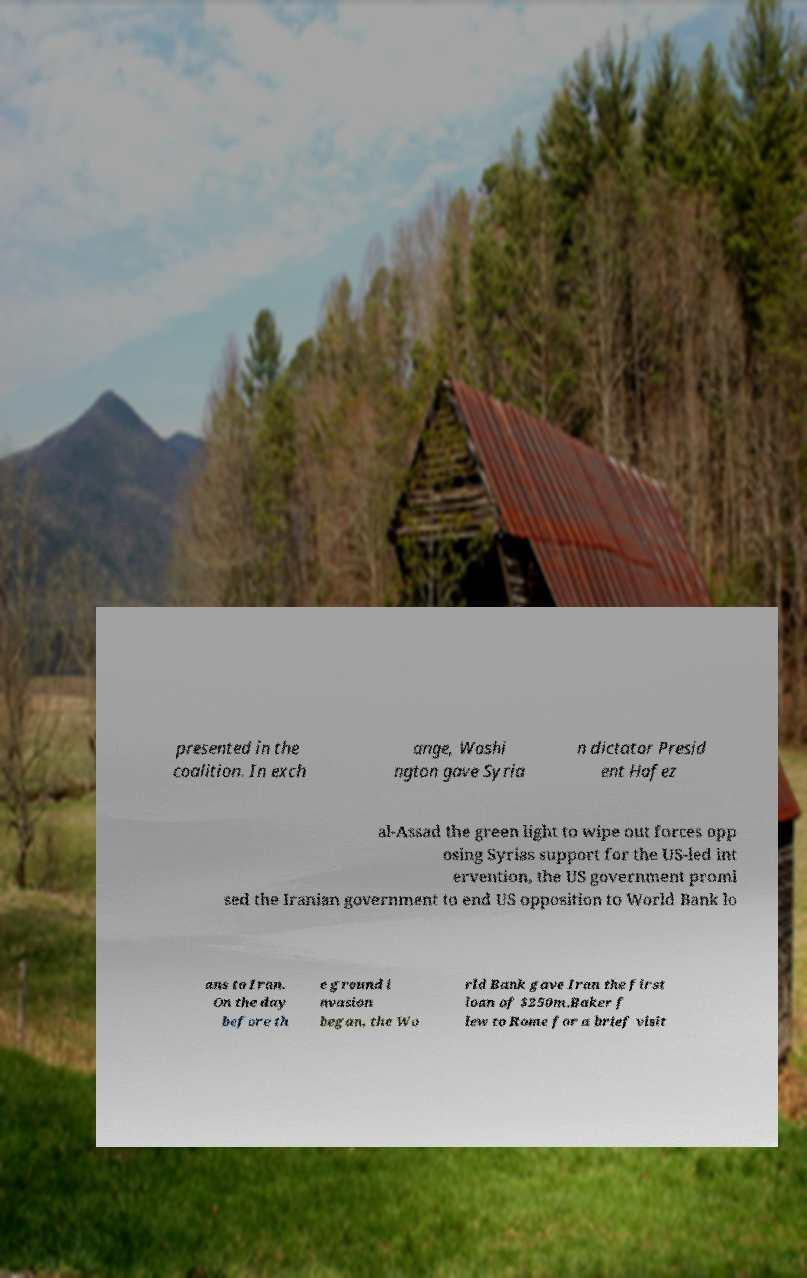Could you assist in decoding the text presented in this image and type it out clearly? presented in the coalition. In exch ange, Washi ngton gave Syria n dictator Presid ent Hafez al-Assad the green light to wipe out forces opp osing Syrias support for the US-led int ervention, the US government promi sed the Iranian government to end US opposition to World Bank lo ans to Iran. On the day before th e ground i nvasion began, the Wo rld Bank gave Iran the first loan of $250m.Baker f lew to Rome for a brief visit 